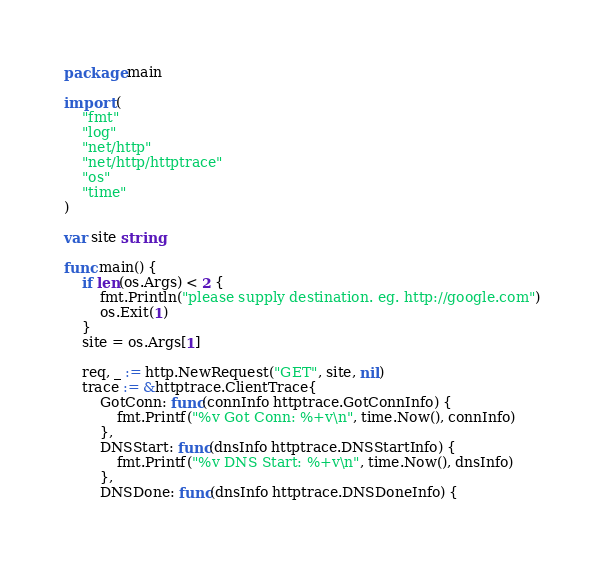<code> <loc_0><loc_0><loc_500><loc_500><_Go_>package main

import (
	"fmt"
	"log"
	"net/http"
	"net/http/httptrace"
	"os"
	"time"
)

var site string

func main() {
	if len(os.Args) < 2 {
		fmt.Println("please supply destination. eg. http://google.com")
		os.Exit(1)
	}
	site = os.Args[1]

	req, _ := http.NewRequest("GET", site, nil)
	trace := &httptrace.ClientTrace{
		GotConn: func(connInfo httptrace.GotConnInfo) {
			fmt.Printf("%v Got Conn: %+v\n", time.Now(), connInfo)
		},
		DNSStart: func(dnsInfo httptrace.DNSStartInfo) {
			fmt.Printf("%v DNS Start: %+v\n", time.Now(), dnsInfo)
		},
		DNSDone: func(dnsInfo httptrace.DNSDoneInfo) {</code> 